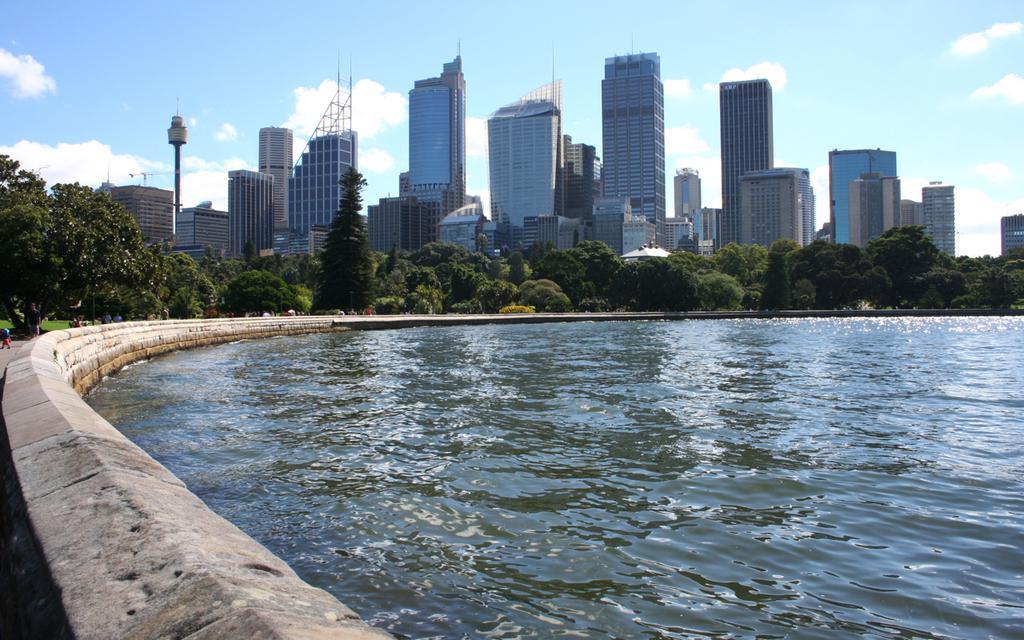Can you describe this image briefly? In this image I can see water, at back I can see trees in green color, buildings in white color, few poles, at top sky is in blue and white color. 